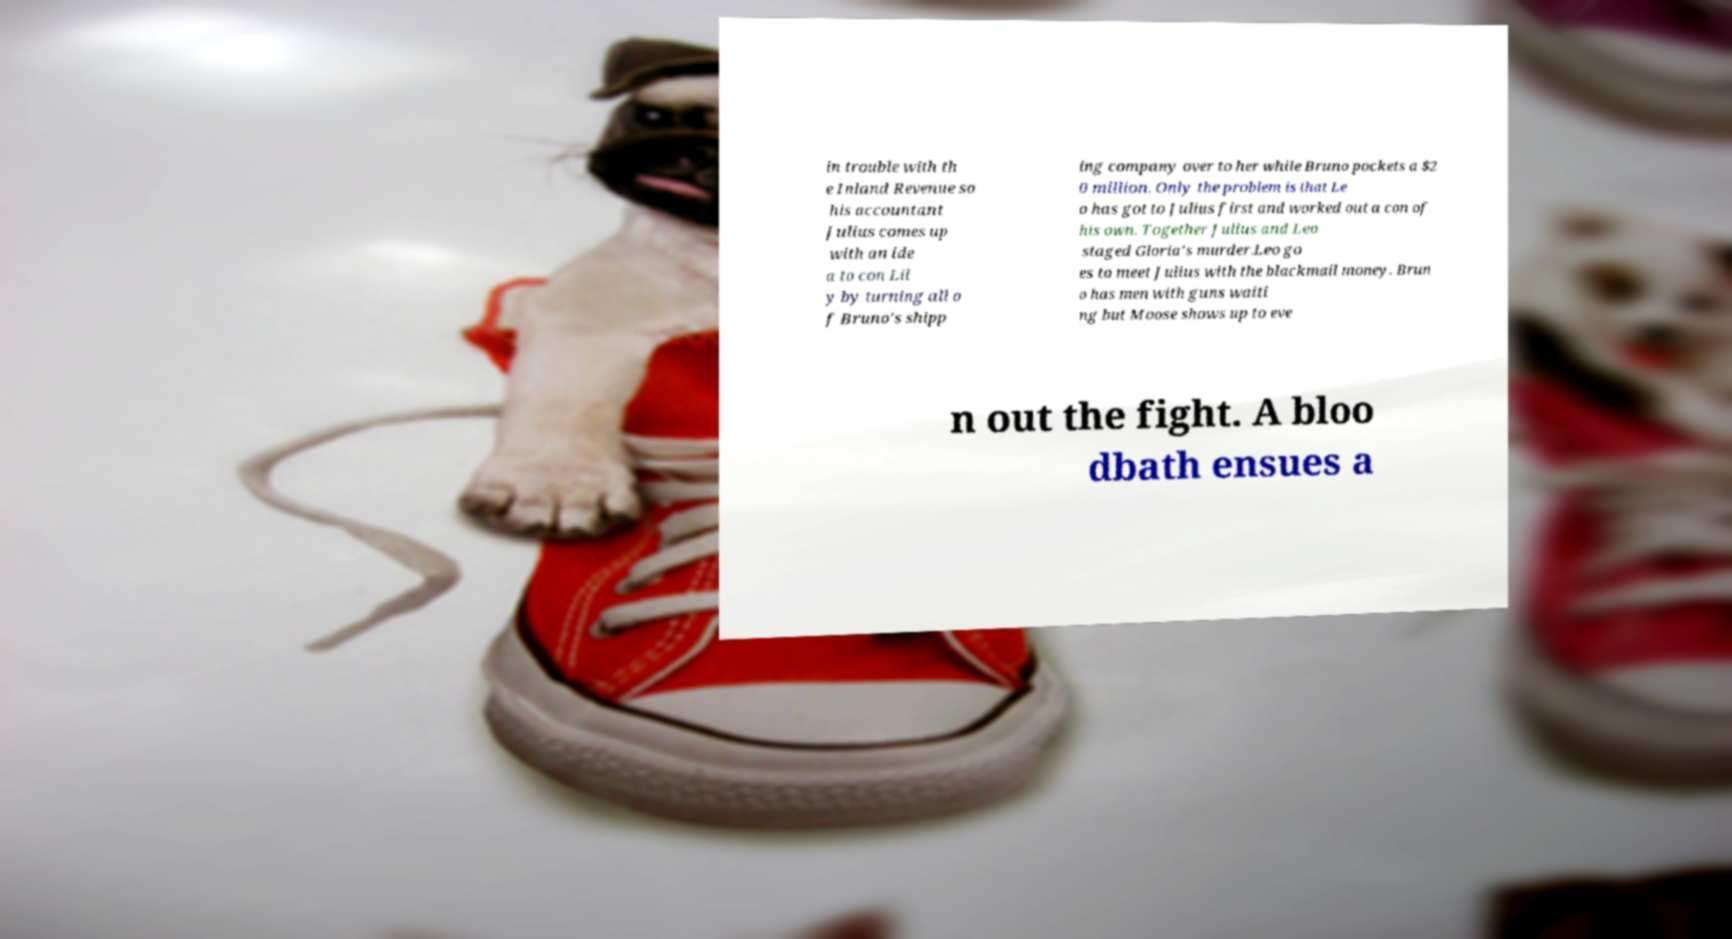Please read and relay the text visible in this image. What does it say? in trouble with th e Inland Revenue so his accountant Julius comes up with an ide a to con Lil y by turning all o f Bruno's shipp ing company over to her while Bruno pockets a $2 0 million. Only the problem is that Le o has got to Julius first and worked out a con of his own. Together Julius and Leo staged Gloria's murder.Leo go es to meet Julius with the blackmail money. Brun o has men with guns waiti ng but Moose shows up to eve n out the fight. A bloo dbath ensues a 